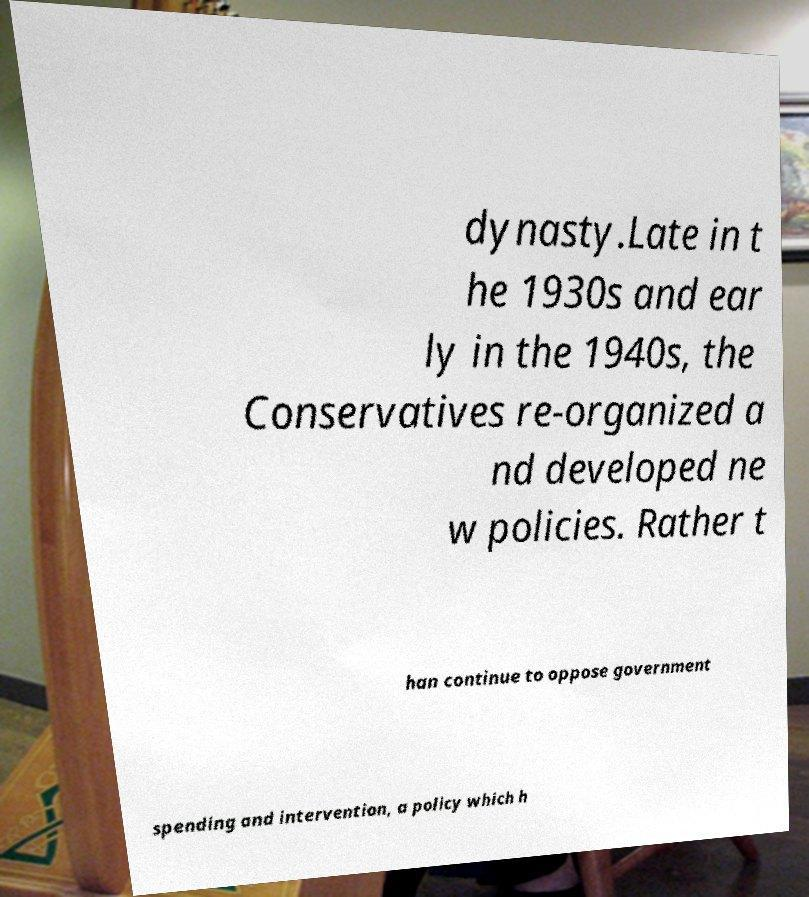Could you assist in decoding the text presented in this image and type it out clearly? dynasty.Late in t he 1930s and ear ly in the 1940s, the Conservatives re-organized a nd developed ne w policies. Rather t han continue to oppose government spending and intervention, a policy which h 